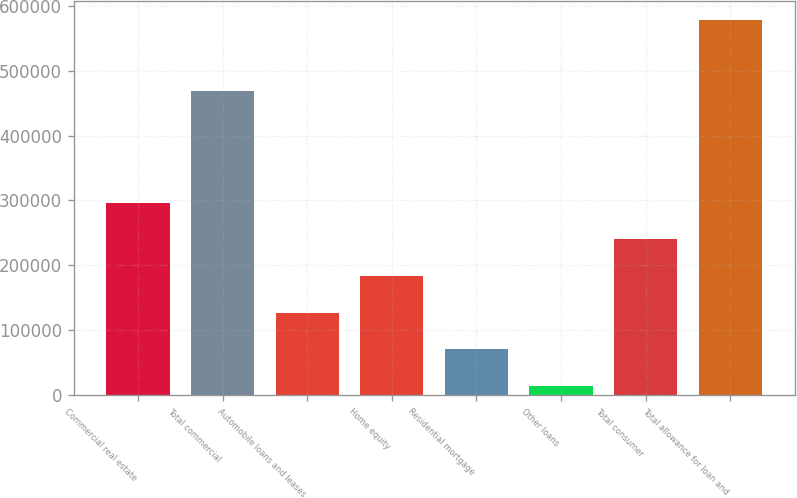Convert chart to OTSL. <chart><loc_0><loc_0><loc_500><loc_500><bar_chart><fcel>Commercial real estate<fcel>Total commercial<fcel>Automobile loans and leases<fcel>Home equity<fcel>Residential mortgage<fcel>Other loans<fcel>Total consumer<fcel>Total allowance for loan and<nl><fcel>296496<fcel>468553<fcel>127329<fcel>183718<fcel>70940.1<fcel>14551<fcel>240107<fcel>578442<nl></chart> 